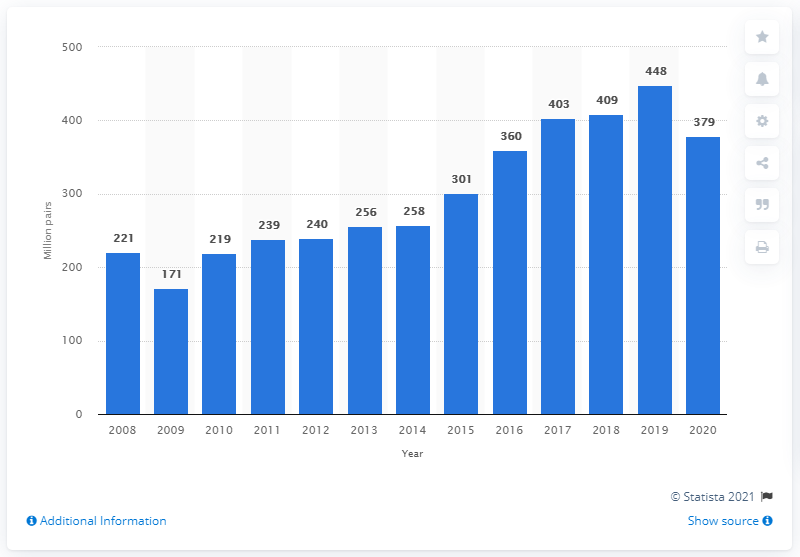Highlight a few significant elements in this photo. In 2020, the adidas Group produced 379 pairs of shoes. 